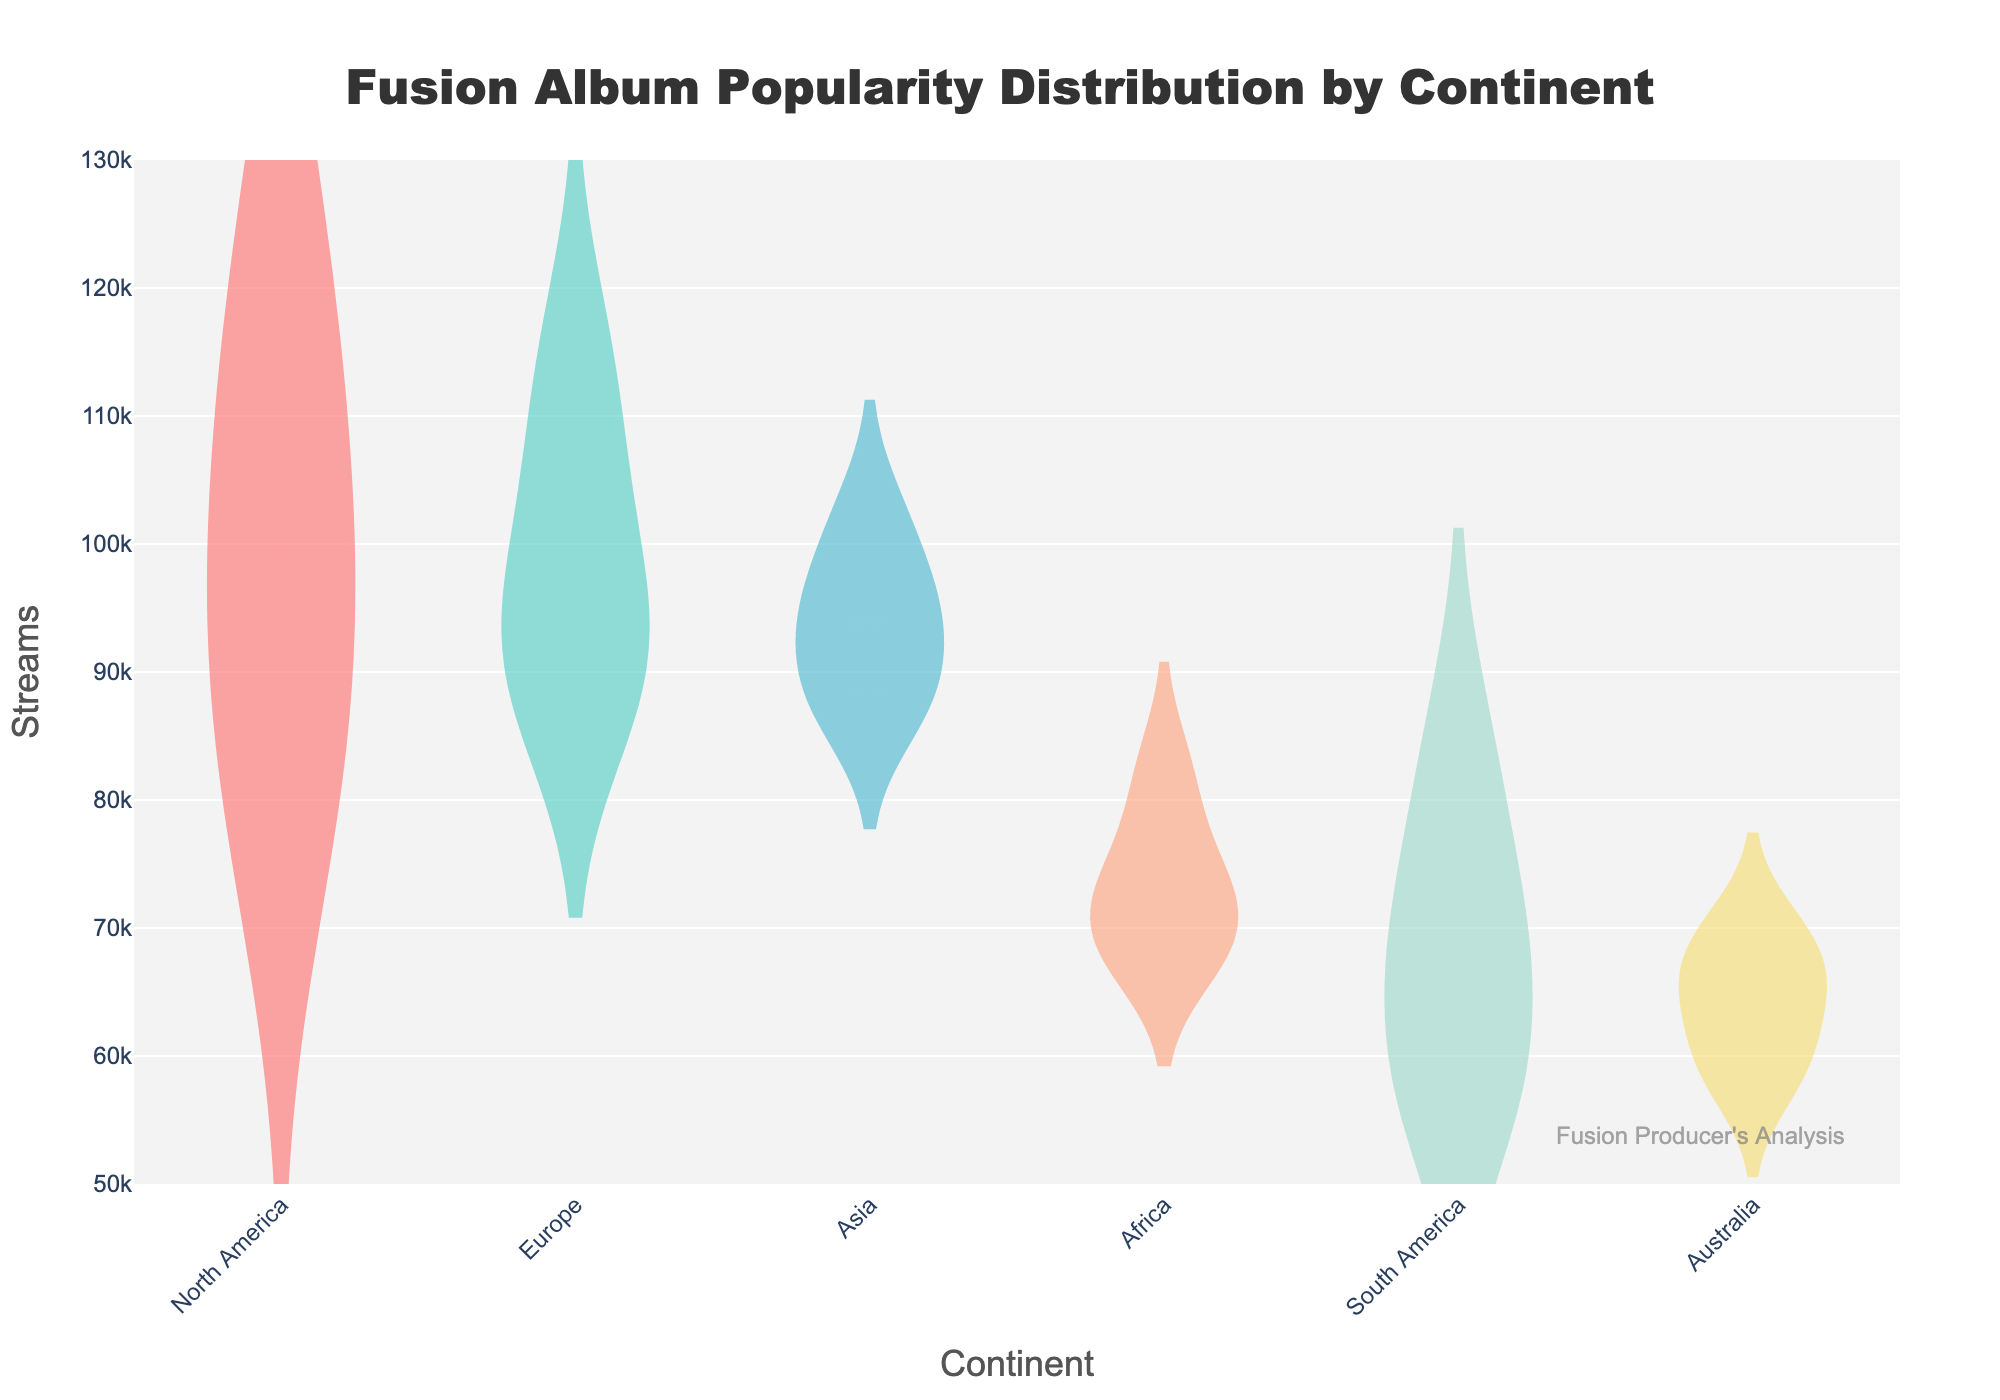How many continents are represented in the plot? The plot shows one violin plot for each represented continent. By counting the distinct violin plots, we can determine the number of continents.
Answer: 6 Which continent has the highest average stream count for fusion albums? By comparing the heights of the mean lines in each violin plot, we can identify the continent with the highest average. North America has the highest mean stream value.
Answer: North America What is the range of stream counts displayed on the y-axis? The y-axis indicates the range of stream values represented in the plot. From the displayed axis labels, we can see the range spans from approximately 50,000 to 130,000 streams.
Answer: 50,000 to 130,000 How does the upper quartile of stream counts for Europe compare to that of South America? By examining the violin plots, we look at the upper quartile marks, which are visualized by the top part of the box plots within the violins. The upper quartile for Europe seems higher than for South America.
Answer: Europe's upper quartile is higher What can you infer about the spread of stream counts for albums from Asia compared to those from Africa? The width and shape of the violin plots indicate the spread. Asia's violin plot is narrower than Africa's, suggesting less variability (spread) in the stream counts for Asian albums.
Answer: Less spread in Asia Which continent has the widest spread of stream counts? By observing the width of the violin plots, the continent with the widest plot represents the greatest variability. Europe appears to have the widest spread.
Answer: Europe Is the median stream count of fusion albums from North America higher than that of Australia? The median is indicated by the central line in the box plot within the violin. By comparing these lines in both continents' plots, we can determine that North America's median is indeed higher.
Answer: Yes What additional insight does the mean line (meanline) provide in this violin plot? The mean line gives a visual indication of the average stream count for albums per continent, which complements the median and quartiles shown in the box plots.
Answer: Average (mean) streams How does the popularity distribution of fusion albums in North America compare to that in Europe? Comparing the overall shape, width, and placement of the violin plots give us insights into the similarities and differences between the distributions. North America's distribution appears more centered with less spread, whereas Europe's is wider and more dispersed.
Answer: North America is more centered; Europe is wider 